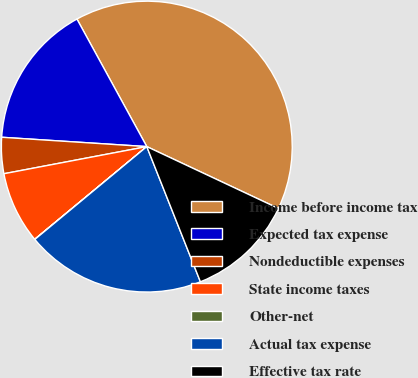<chart> <loc_0><loc_0><loc_500><loc_500><pie_chart><fcel>Income before income tax<fcel>Expected tax expense<fcel>Nondeductible expenses<fcel>State income taxes<fcel>Other-net<fcel>Actual tax expense<fcel>Effective tax rate<nl><fcel>39.96%<fcel>16.0%<fcel>4.01%<fcel>8.01%<fcel>0.02%<fcel>19.99%<fcel>12.0%<nl></chart> 